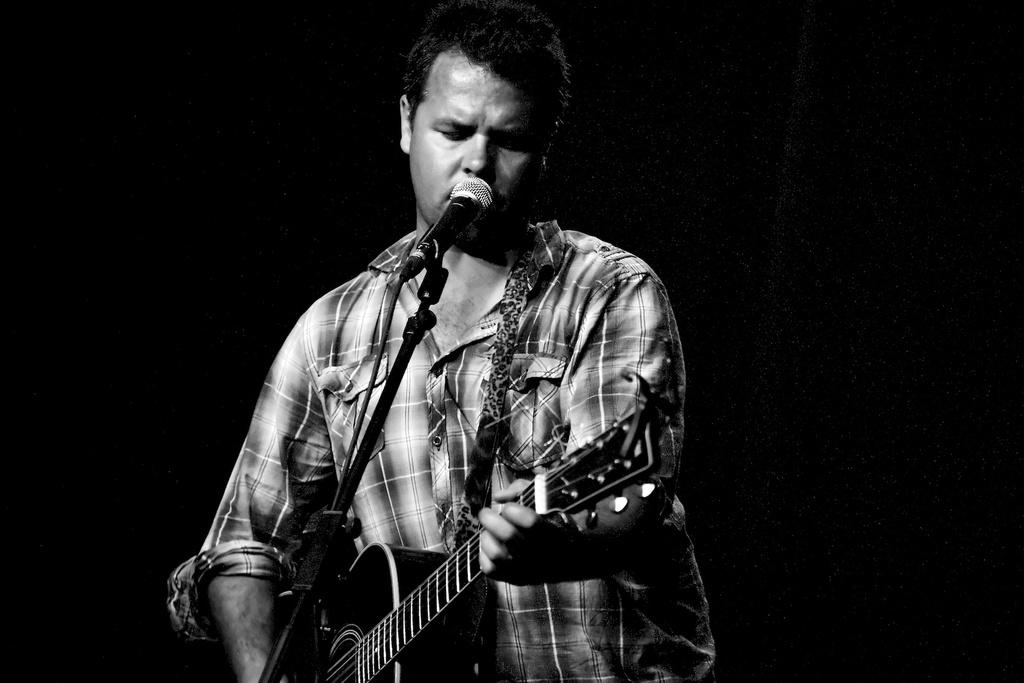What is the color scheme of the image? The image is black and white. Who is present in the image? There is a man in the image. What is the man doing in the image? The man is standing in front of a microphone and playing a guitar. What type of throne can be seen behind the man in the image? There is no throne present in the image; it features a man standing in front of a microphone and playing a guitar. How many songs is the man singing in the image? The image does not show the man singing, so it cannot be determined how many songs he might be singing. 